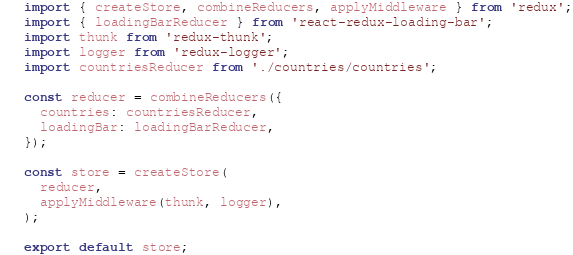<code> <loc_0><loc_0><loc_500><loc_500><_JavaScript_>import { createStore, combineReducers, applyMiddleware } from 'redux';
import { loadingBarReducer } from 'react-redux-loading-bar';
import thunk from 'redux-thunk';
import logger from 'redux-logger';
import countriesReducer from './countries/countries';

const reducer = combineReducers({
  countries: countriesReducer,
  loadingBar: loadingBarReducer,
});

const store = createStore(
  reducer,
  applyMiddleware(thunk, logger),
);

export default store;
</code> 